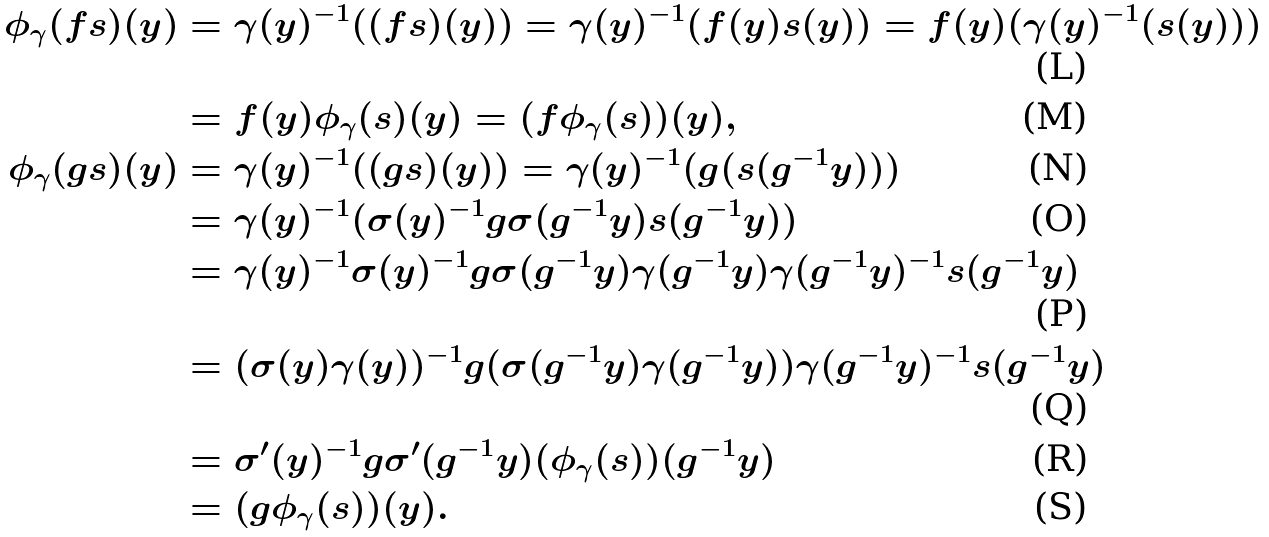Convert formula to latex. <formula><loc_0><loc_0><loc_500><loc_500>\phi _ { \gamma } ( f s ) ( y ) & = \gamma ( y ) ^ { - 1 } ( ( f s ) ( y ) ) = \gamma ( y ) ^ { - 1 } ( f ( y ) s ( y ) ) = f ( y ) ( \gamma ( y ) ^ { - 1 } ( s ( y ) ) ) \\ & = f ( y ) \phi _ { \gamma } ( s ) ( y ) = ( f \phi _ { \gamma } ( s ) ) ( y ) , \\ \phi _ { \gamma } ( g s ) ( y ) & = \gamma ( y ) ^ { - 1 } ( ( g s ) ( y ) ) = \gamma ( y ) ^ { - 1 } ( g ( s ( g ^ { - 1 } y ) ) ) \\ & = \gamma ( y ) ^ { - 1 } ( \sigma ( y ) ^ { - 1 } g \sigma ( g ^ { - 1 } y ) s ( g ^ { - 1 } y ) ) \\ & = \gamma ( y ) ^ { - 1 } \sigma ( y ) ^ { - 1 } g \sigma ( g ^ { - 1 } y ) \gamma ( g ^ { - 1 } y ) \gamma ( g ^ { - 1 } y ) ^ { - 1 } s ( g ^ { - 1 } y ) \\ & = ( \sigma ( y ) \gamma ( y ) ) ^ { - 1 } g ( \sigma ( g ^ { - 1 } y ) \gamma ( g ^ { - 1 } y ) ) \gamma ( g ^ { - 1 } y ) ^ { - 1 } s ( g ^ { - 1 } y ) \\ & = \sigma ^ { \prime } ( y ) ^ { - 1 } g \sigma ^ { \prime } ( g ^ { - 1 } y ) ( \phi _ { \gamma } ( s ) ) ( g ^ { - 1 } y ) \\ & = ( g \phi _ { \gamma } ( s ) ) ( y ) .</formula> 